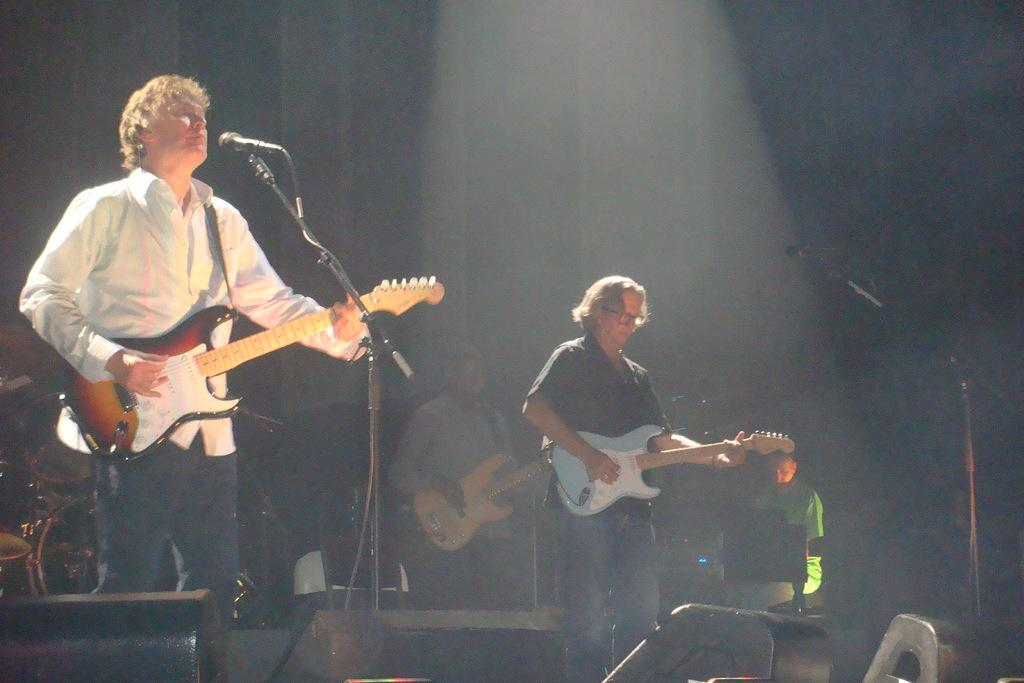How many people are in the image? There are four men in the image. What are three of the men doing in the image? Three of the men are playing guitars. What object is in front of the men playing guitars? There is a microphone in front of the men playing guitars. What type of pie is being served to the snail in the image? There is no pie or snail present in the image; it features four men, three of whom are playing guitars, and a microphone. How many children are visible in the image? There are no children present in the image; it features four men, three of whom are playing guitars, and a microphone. 